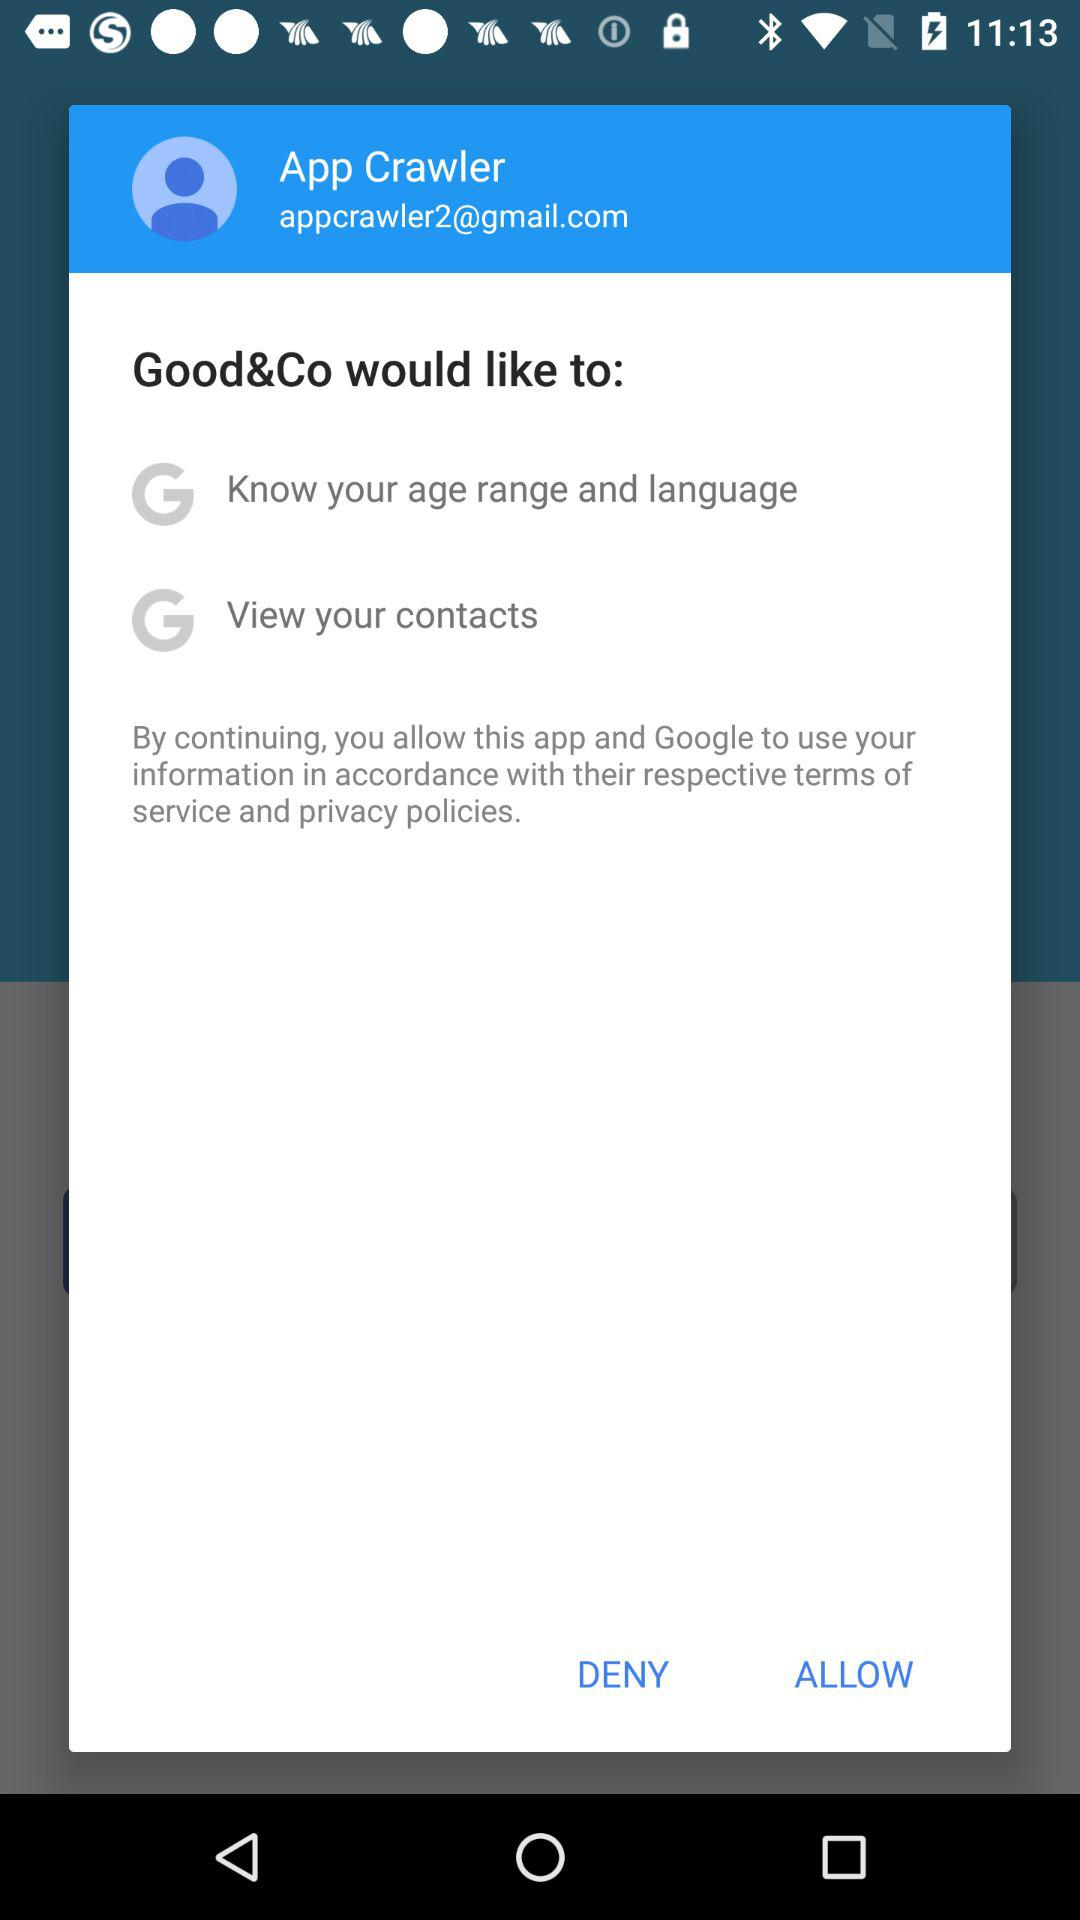What is the email address? The email address is appcrawler2@gmail.com. 